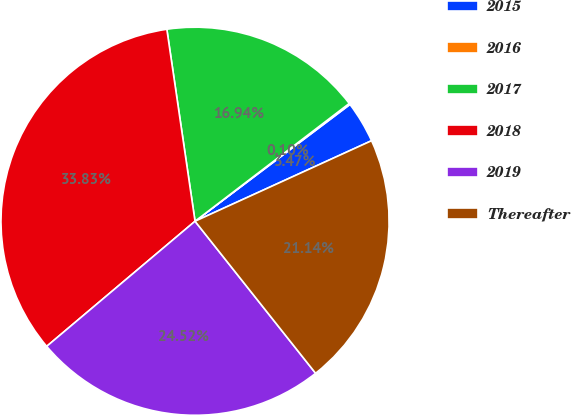<chart> <loc_0><loc_0><loc_500><loc_500><pie_chart><fcel>2015<fcel>2016<fcel>2017<fcel>2018<fcel>2019<fcel>Thereafter<nl><fcel>3.47%<fcel>0.1%<fcel>16.94%<fcel>33.83%<fcel>24.52%<fcel>21.14%<nl></chart> 